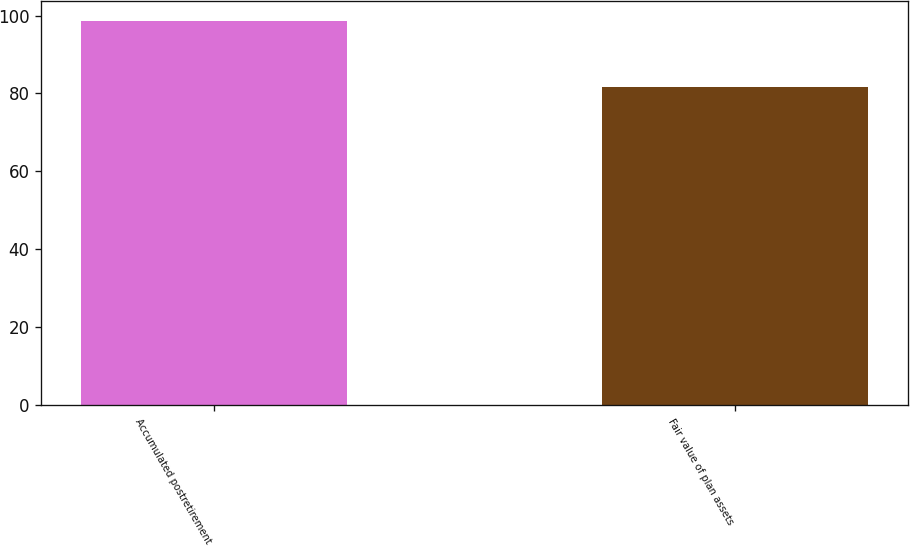Convert chart to OTSL. <chart><loc_0><loc_0><loc_500><loc_500><bar_chart><fcel>Accumulated postretirement<fcel>Fair value of plan assets<nl><fcel>98.7<fcel>81.7<nl></chart> 